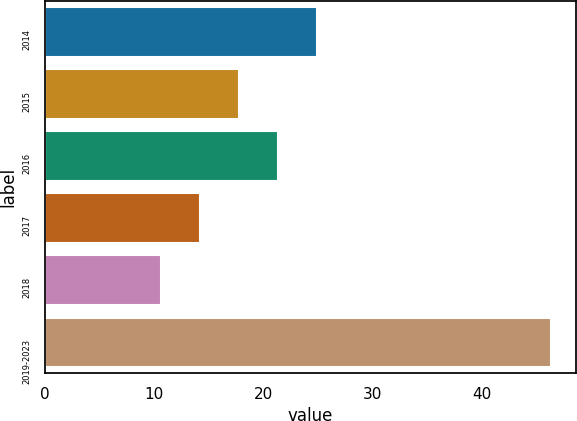<chart> <loc_0><loc_0><loc_500><loc_500><bar_chart><fcel>2014<fcel>2015<fcel>2016<fcel>2017<fcel>2018<fcel>2019-2023<nl><fcel>24.88<fcel>17.74<fcel>21.31<fcel>14.17<fcel>10.6<fcel>46.3<nl></chart> 